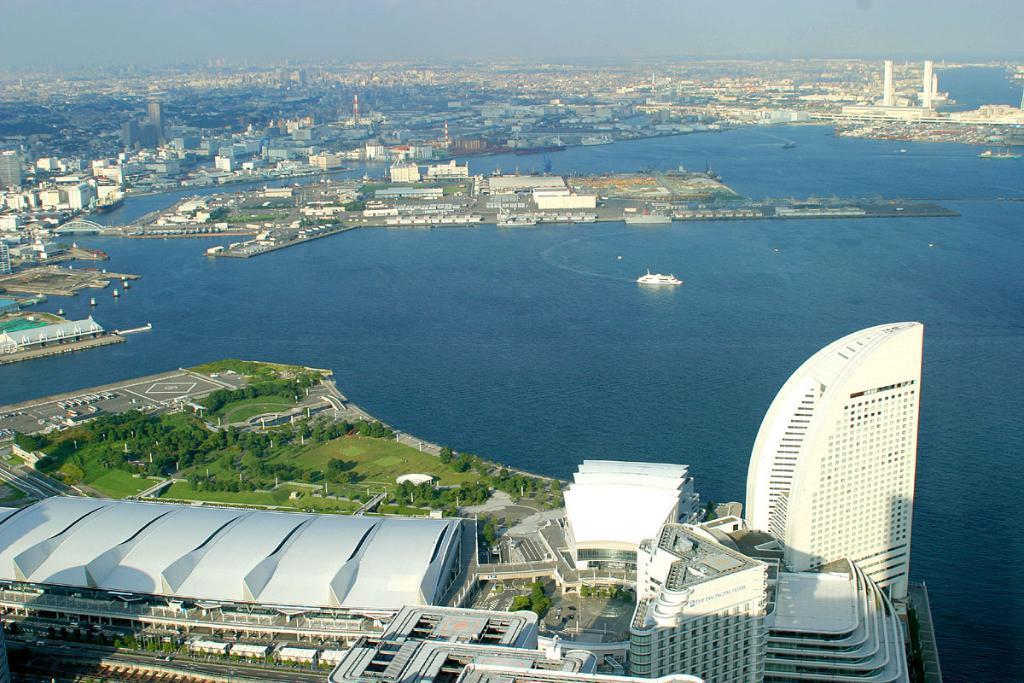Can you describe this image briefly? In this image we can see water, ship, buildings, trees, sky, road, vehicles and towers. In the background there is a sky. 